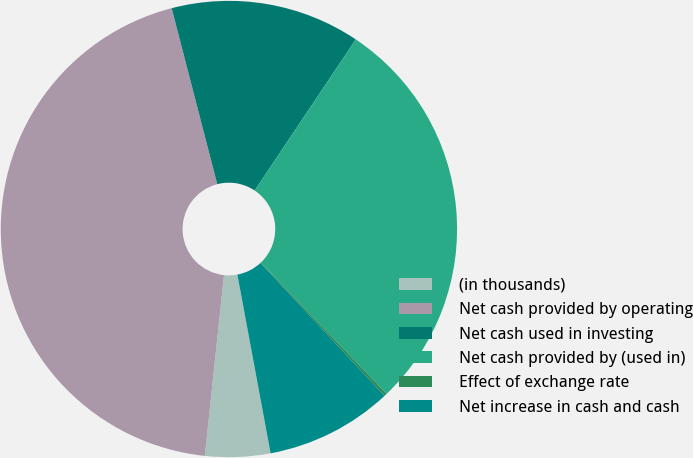<chart> <loc_0><loc_0><loc_500><loc_500><pie_chart><fcel>(in thousands)<fcel>Net cash provided by operating<fcel>Net cash used in investing<fcel>Net cash provided by (used in)<fcel>Effect of exchange rate<fcel>Net increase in cash and cash<nl><fcel>4.61%<fcel>44.28%<fcel>13.42%<fcel>28.47%<fcel>0.2%<fcel>9.02%<nl></chart> 